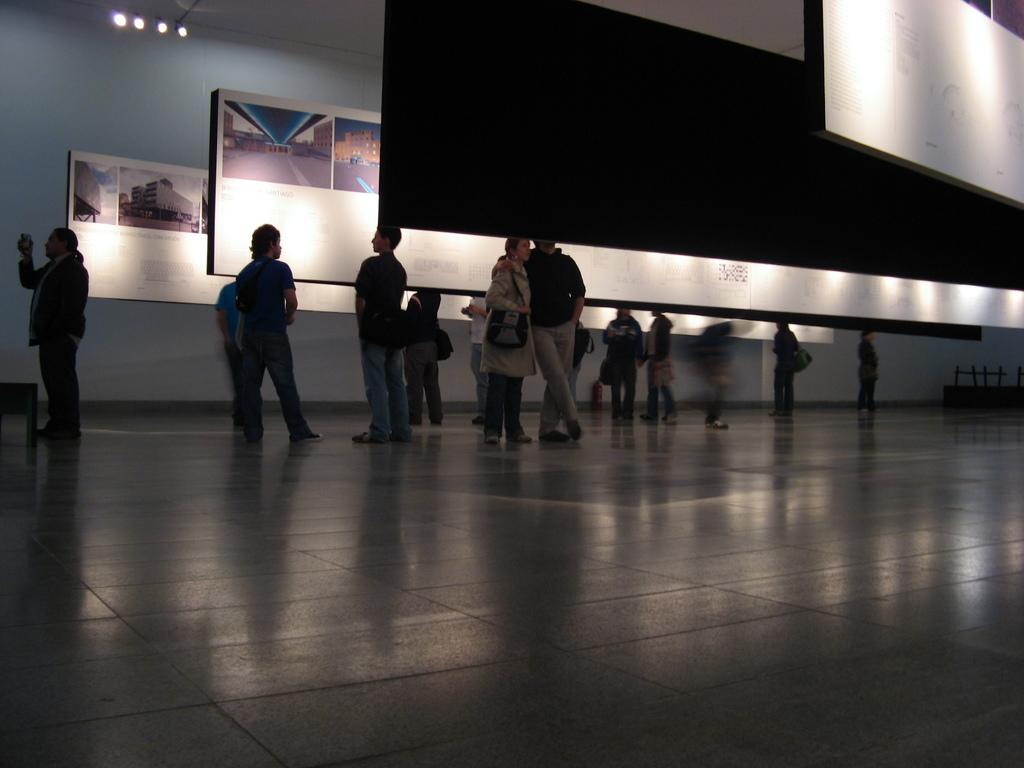What can be seen in the image? There are people standing in the image. Where are the people standing? The people are standing on the floor. What can be seen in the background of the image? There are three whiteboards and a blackboard in the background of the image. How is the blackboard positioned in the image? The blackboard is hanged from the ceiling. What type of pot is being used to design the manager's office in the image? There is no pot or mention of a manager's office in the image. 